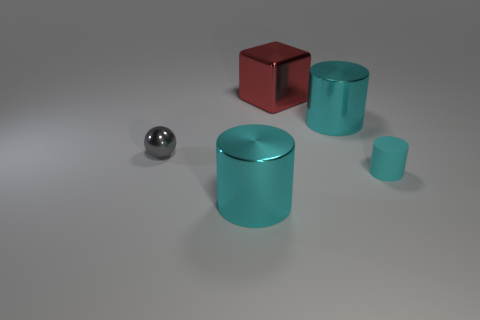There is a cylinder that is left of the big cyan metallic cylinder that is to the right of the red shiny block; how many small cylinders are in front of it? In the perspective of the image, there are no small cylinders located in front of the large cyan metallic cylinder that is situated to the left of it and to the right of the red shiny block. 